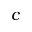Convert formula to latex. <formula><loc_0><loc_0><loc_500><loc_500>c</formula> 